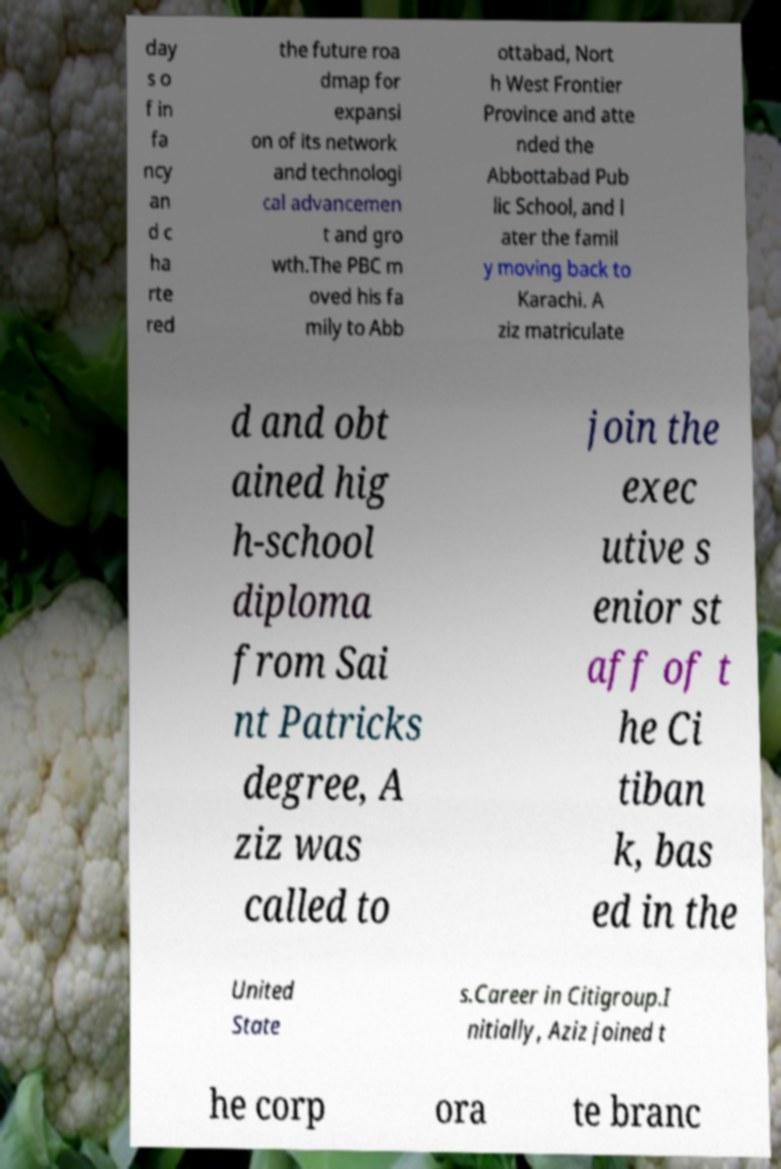Please identify and transcribe the text found in this image. day s o f in fa ncy an d c ha rte red the future roa dmap for expansi on of its network and technologi cal advancemen t and gro wth.The PBC m oved his fa mily to Abb ottabad, Nort h West Frontier Province and atte nded the Abbottabad Pub lic School, and l ater the famil y moving back to Karachi. A ziz matriculate d and obt ained hig h-school diploma from Sai nt Patricks degree, A ziz was called to join the exec utive s enior st aff of t he Ci tiban k, bas ed in the United State s.Career in Citigroup.I nitially, Aziz joined t he corp ora te branc 